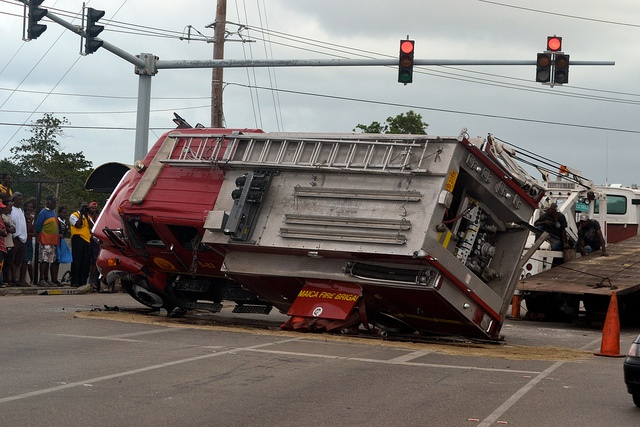Describe the objects in this image and their specific colors. I can see truck in darkgray, black, gray, and maroon tones, people in darkgray, black, olive, gray, and maroon tones, people in darkgray, black, and gray tones, people in darkgray, black, maroon, gray, and navy tones, and traffic light in darkgray, black, gray, and lightgray tones in this image. 